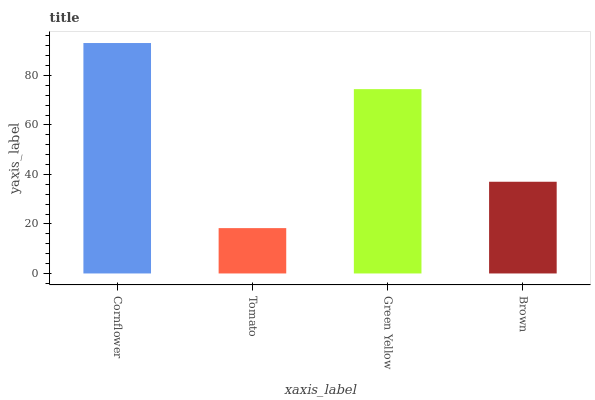Is Tomato the minimum?
Answer yes or no. Yes. Is Cornflower the maximum?
Answer yes or no. Yes. Is Green Yellow the minimum?
Answer yes or no. No. Is Green Yellow the maximum?
Answer yes or no. No. Is Green Yellow greater than Tomato?
Answer yes or no. Yes. Is Tomato less than Green Yellow?
Answer yes or no. Yes. Is Tomato greater than Green Yellow?
Answer yes or no. No. Is Green Yellow less than Tomato?
Answer yes or no. No. Is Green Yellow the high median?
Answer yes or no. Yes. Is Brown the low median?
Answer yes or no. Yes. Is Cornflower the high median?
Answer yes or no. No. Is Green Yellow the low median?
Answer yes or no. No. 